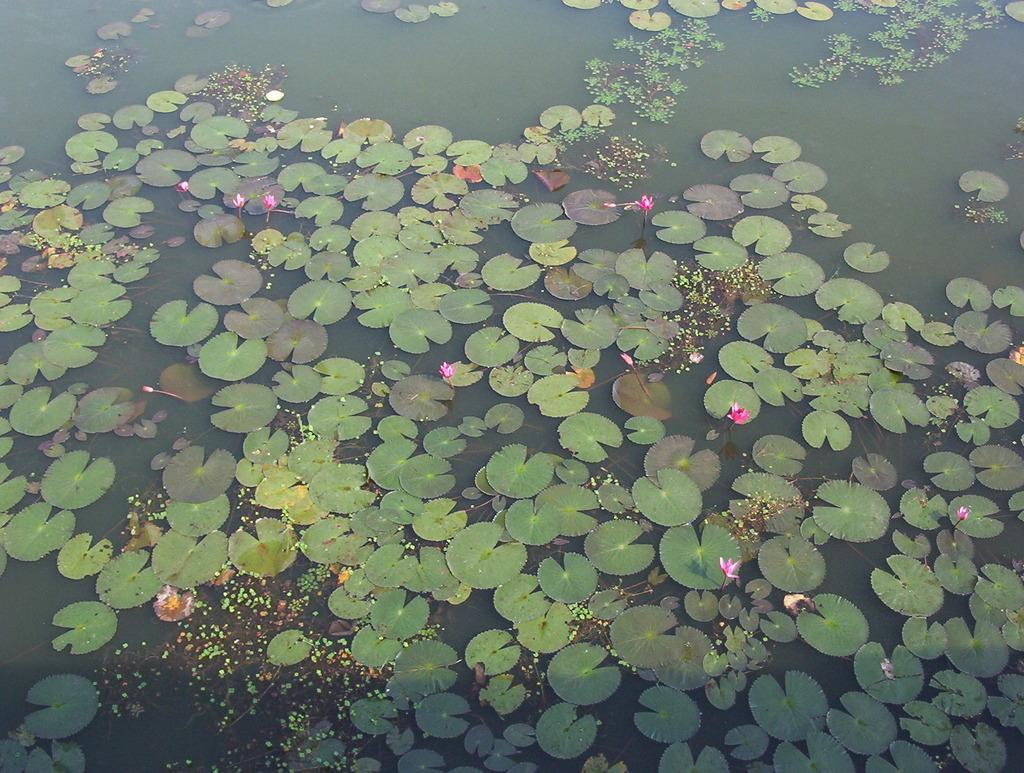What type of plants can be seen in the image? There are lotus plants in the image. What parts of the plants are visible in the image? There are leaves in the image. Can you tell if the image was taken during the day or night? The image appears to be taken during the day. What type of request is being made in the image? There is no request present in the image; it features lotus plants and leaves. How does the digestion process of the lotus plants appear in the image? The image does not show the digestion process of the lotus plants; it only shows the plants and leaves. 